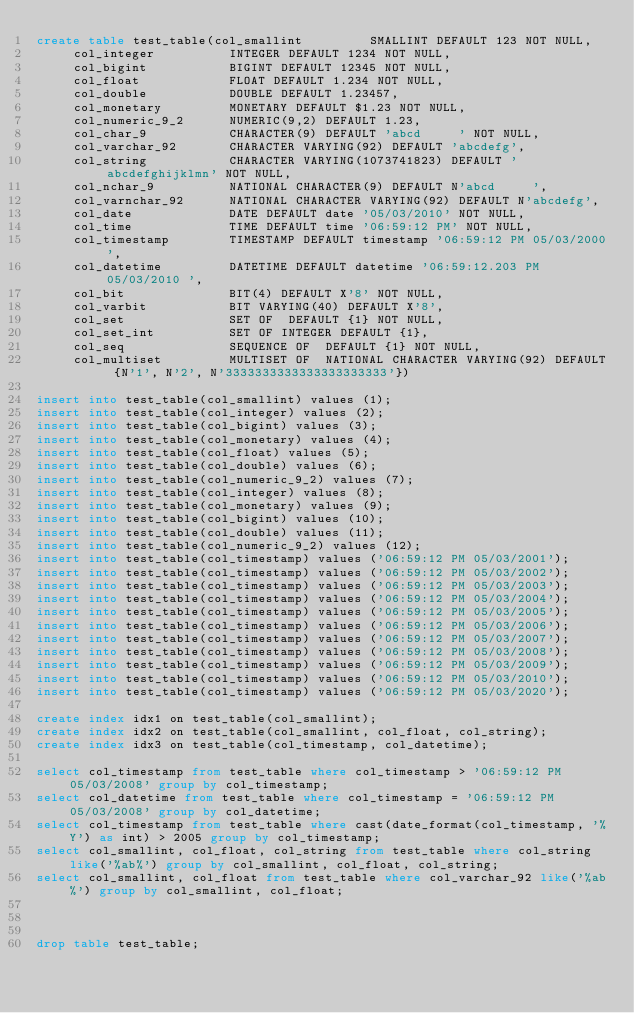Convert code to text. <code><loc_0><loc_0><loc_500><loc_500><_SQL_>create table test_table(col_smallint         SMALLINT DEFAULT 123 NOT NULL,
     col_integer          INTEGER DEFAULT 1234 NOT NULL,
     col_bigint           BIGINT DEFAULT 12345 NOT NULL,
     col_float            FLOAT DEFAULT 1.234 NOT NULL,
     col_double           DOUBLE DEFAULT 1.23457,
     col_monetary         MONETARY DEFAULT $1.23 NOT NULL,
     col_numeric_9_2      NUMERIC(9,2) DEFAULT 1.23,
     col_char_9           CHARACTER(9) DEFAULT 'abcd     ' NOT NULL,
     col_varchar_92       CHARACTER VARYING(92) DEFAULT 'abcdefg',
     col_string           CHARACTER VARYING(1073741823) DEFAULT 'abcdefghijklmn' NOT NULL,
     col_nchar_9          NATIONAL CHARACTER(9) DEFAULT N'abcd     ',
     col_varnchar_92      NATIONAL CHARACTER VARYING(92) DEFAULT N'abcdefg',
     col_date             DATE DEFAULT date '05/03/2010' NOT NULL,
     col_time             TIME DEFAULT time '06:59:12 PM' NOT NULL,
     col_timestamp        TIMESTAMP DEFAULT timestamp '06:59:12 PM 05/03/2000',
     col_datetime         DATETIME DEFAULT datetime '06:59:12.203 PM 05/03/2010 ',
     col_bit              BIT(4) DEFAULT X'8' NOT NULL,
     col_varbit           BIT VARYING(40) DEFAULT X'8',
     col_set              SET OF  DEFAULT {1} NOT NULL,
     col_set_int          SET OF INTEGER DEFAULT {1},
     col_seq              SEQUENCE OF  DEFAULT {1} NOT NULL,
     col_multiset         MULTISET OF  NATIONAL CHARACTER VARYING(92) DEFAULT {N'1', N'2', N'3333333333333333333333'})

insert into test_table(col_smallint) values (1);
insert into test_table(col_integer) values (2);
insert into test_table(col_bigint) values (3);
insert into test_table(col_monetary) values (4);
insert into test_table(col_float) values (5);
insert into test_table(col_double) values (6);
insert into test_table(col_numeric_9_2) values (7);
insert into test_table(col_integer) values (8);
insert into test_table(col_monetary) values (9);
insert into test_table(col_bigint) values (10);
insert into test_table(col_double) values (11);
insert into test_table(col_numeric_9_2) values (12);
insert into test_table(col_timestamp) values ('06:59:12 PM 05/03/2001');
insert into test_table(col_timestamp) values ('06:59:12 PM 05/03/2002');
insert into test_table(col_timestamp) values ('06:59:12 PM 05/03/2003');
insert into test_table(col_timestamp) values ('06:59:12 PM 05/03/2004');
insert into test_table(col_timestamp) values ('06:59:12 PM 05/03/2005');
insert into test_table(col_timestamp) values ('06:59:12 PM 05/03/2006');
insert into test_table(col_timestamp) values ('06:59:12 PM 05/03/2007');
insert into test_table(col_timestamp) values ('06:59:12 PM 05/03/2008');
insert into test_table(col_timestamp) values ('06:59:12 PM 05/03/2009');
insert into test_table(col_timestamp) values ('06:59:12 PM 05/03/2010');
insert into test_table(col_timestamp) values ('06:59:12 PM 05/03/2020');

create index idx1 on test_table(col_smallint);
create index idx2 on test_table(col_smallint, col_float, col_string);
create index idx3 on test_table(col_timestamp, col_datetime);

select col_timestamp from test_table where col_timestamp > '06:59:12 PM 05/03/2008' group by col_timestamp;
select col_datetime from test_table where col_timestamp = '06:59:12 PM 05/03/2008' group by col_datetime;
select col_timestamp from test_table where cast(date_format(col_timestamp, '%Y') as int) > 2005 group by col_timestamp;
select col_smallint, col_float, col_string from test_table where col_string like('%ab%') group by col_smallint, col_float, col_string;
select col_smallint, col_float from test_table where col_varchar_92 like('%ab%') group by col_smallint, col_float;



drop table test_table;
</code> 